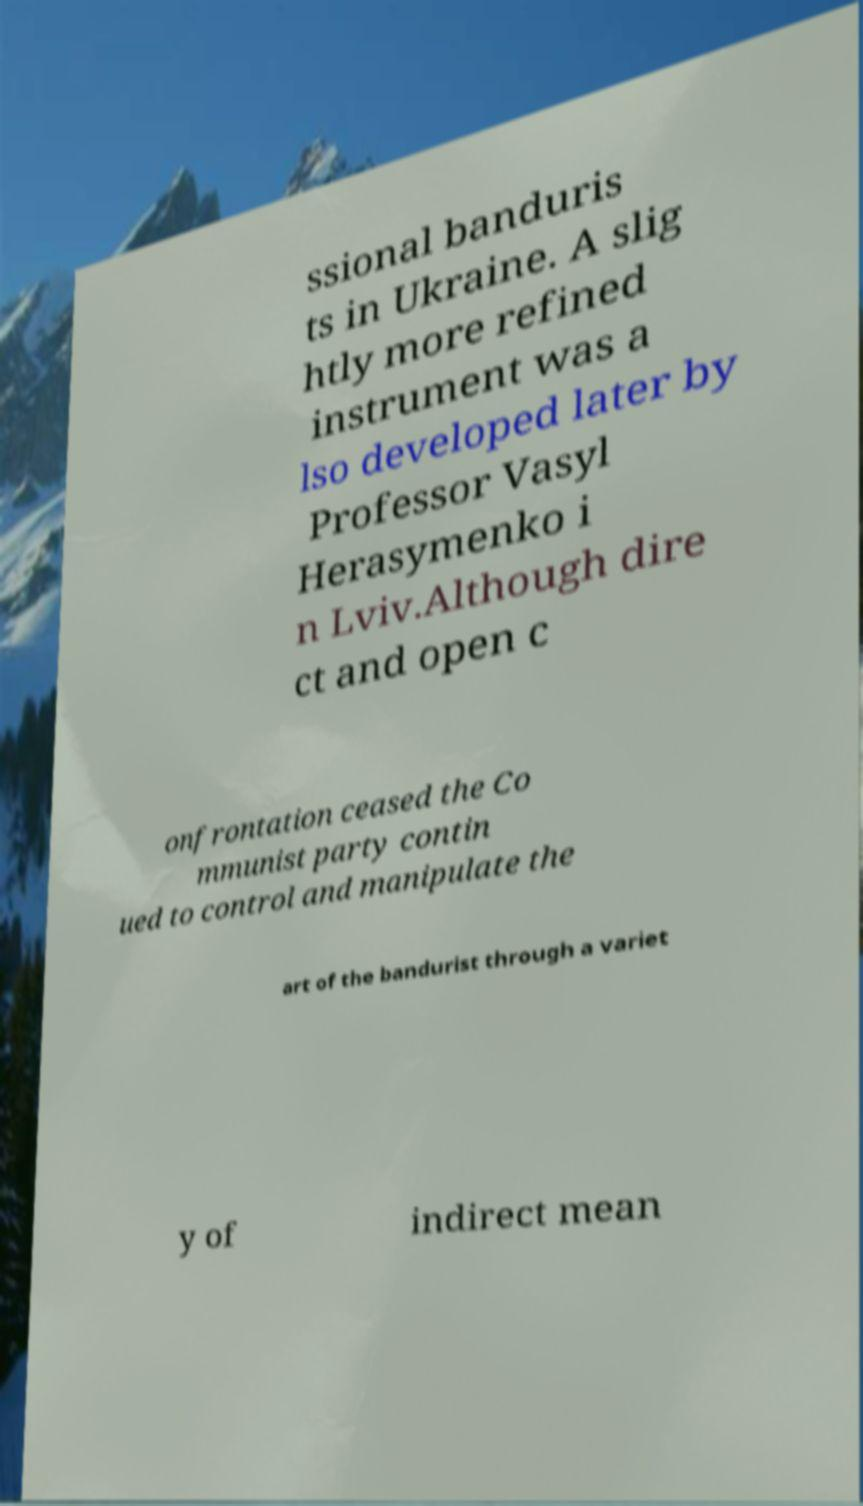Please read and relay the text visible in this image. What does it say? ssional banduris ts in Ukraine. A slig htly more refined instrument was a lso developed later by Professor Vasyl Herasymenko i n Lviv.Although dire ct and open c onfrontation ceased the Co mmunist party contin ued to control and manipulate the art of the bandurist through a variet y of indirect mean 